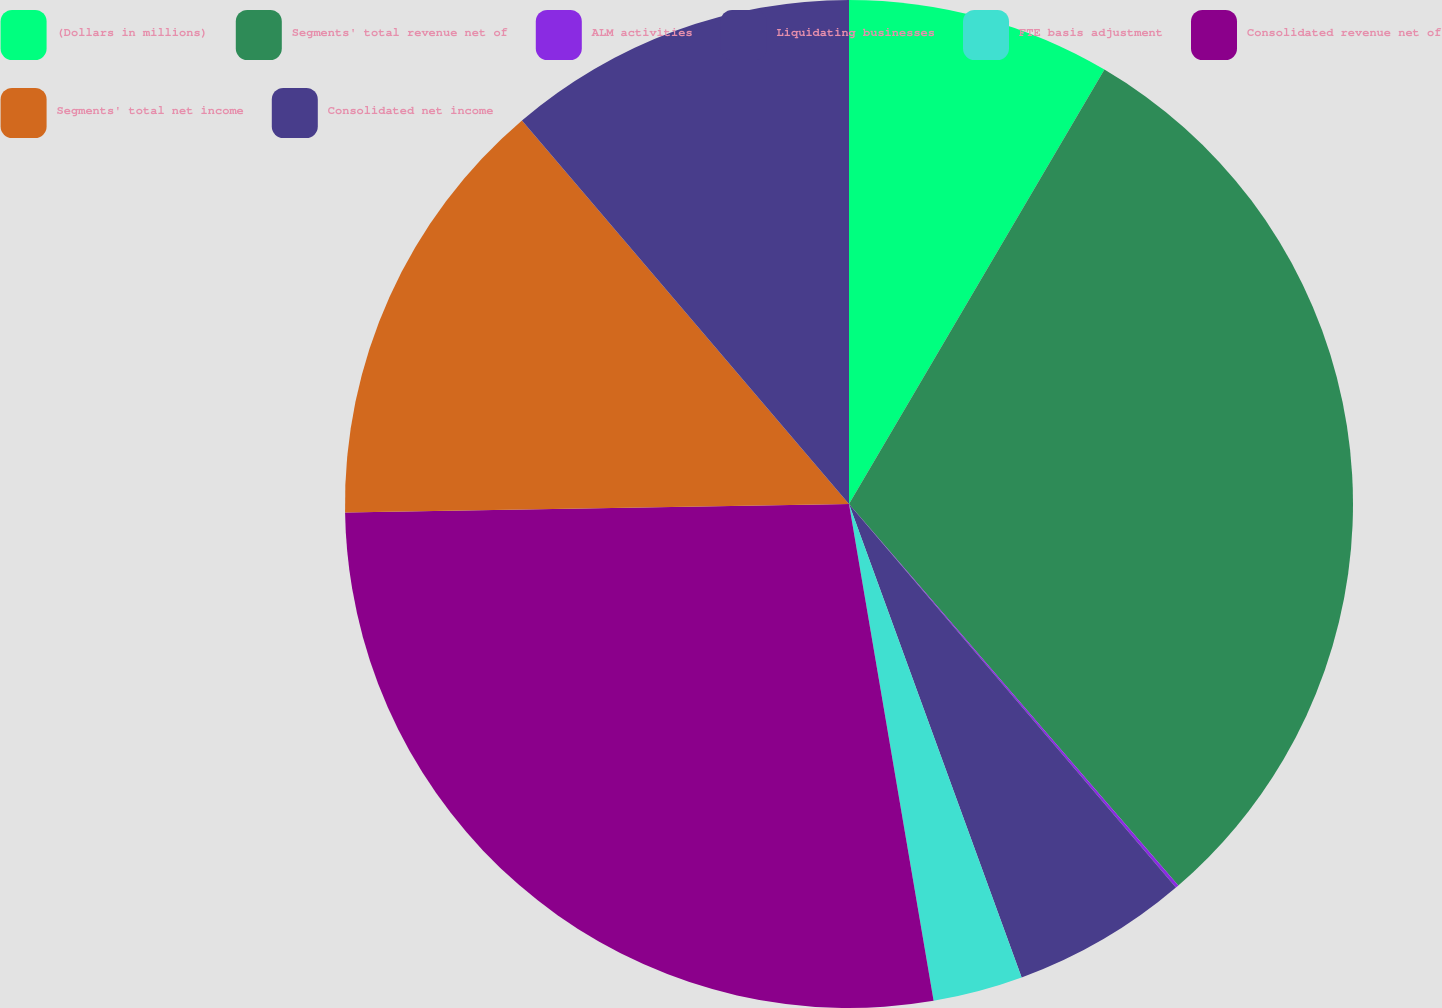Convert chart. <chart><loc_0><loc_0><loc_500><loc_500><pie_chart><fcel>(Dollars in millions)<fcel>Segments' total revenue net of<fcel>ALM activities<fcel>Liquidating businesses<fcel>FTE basis adjustment<fcel>Consolidated revenue net of<fcel>Segments' total net income<fcel>Consolidated net income<nl><fcel>8.46%<fcel>30.21%<fcel>0.1%<fcel>5.67%<fcel>2.88%<fcel>27.42%<fcel>14.03%<fcel>11.24%<nl></chart> 